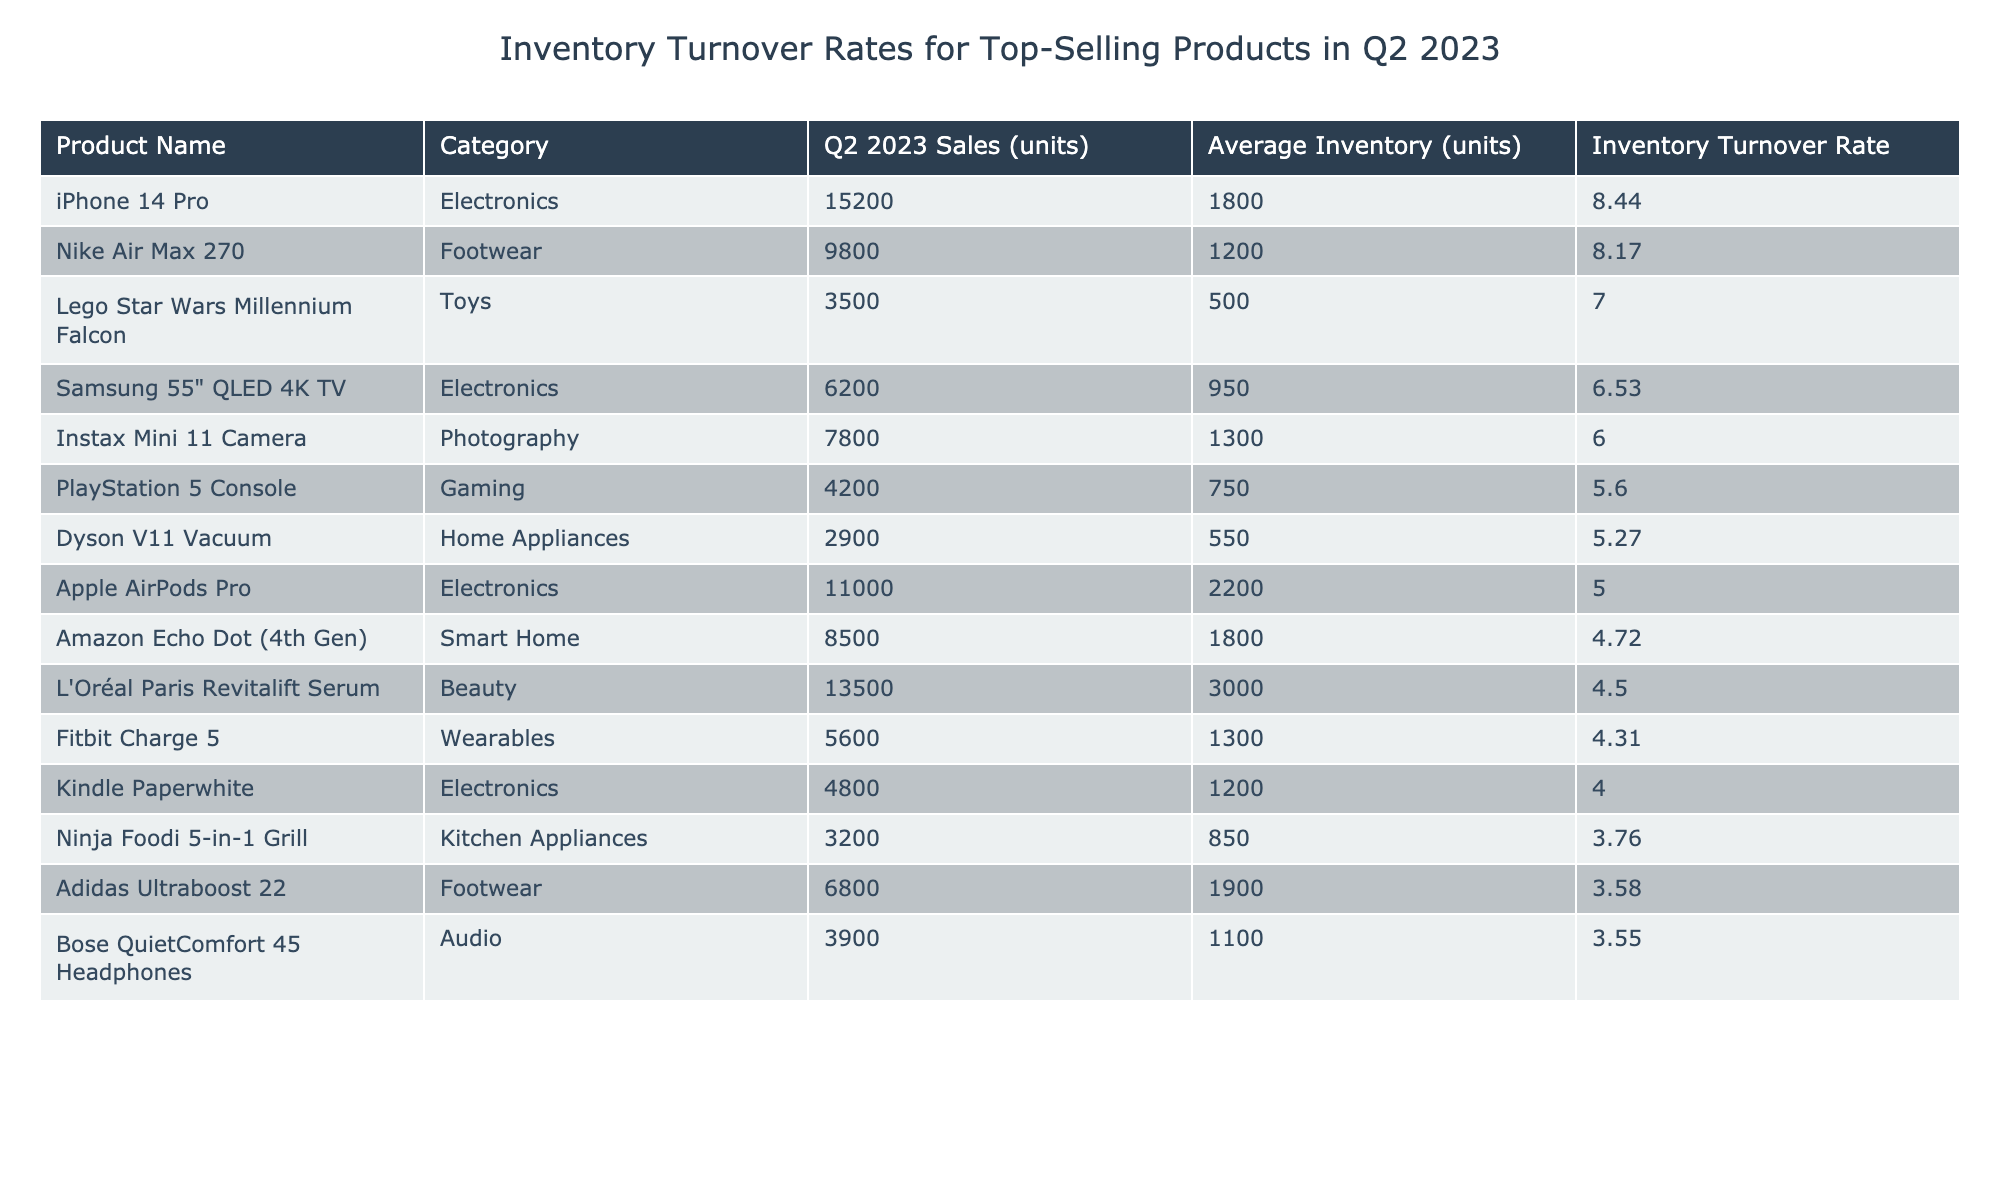What is the highest inventory turnover rate among the listed products? The highest inventory turnover rate is found by visually scanning the "Inventory Turnover Rate" column and identifying the top value, which is 8.44 for the iPhone 14 Pro.
Answer: 8.44 Which product has the lowest inventory turnover rate? The product with the lowest inventory turnover rate can be determined by looking for the smallest value in the "Inventory Turnover Rate" column, which is 3.55 for the Bose QuietComfort 45 Headphones.
Answer: 3.55 How many units of the PlayStation 5 Console were sold in Q2 2023? The Q2 2023 sales can be found by referring to the "Q2 2023 Sales (units)" column and looking for the corresponding row for the PlayStation 5 Console, which shows sales of 4200 units.
Answer: 4200 What is the average inventory turnover rate of all products listed? The average inventory turnover rate can be calculated by summing all turnover rates and dividing by the number of products. Adding the rates gives a total of 61.19 and dividing by 15 products results in approximately 4.08.
Answer: 4.08 Is the inventory turnover rate for the Amazon Echo Dot (4th Gen) above or below the average inventory turnover rate? First, we need to calculate the average turnover rate, which is 4.08. Then, comparing this with the turnover rate for the Amazon Echo Dot (4th Gen), which is 4.72, we can conclude that 4.72 is above 4.08.
Answer: Above How many more units of the Nike Air Max 270 were sold compared to the Dyson V11 Vacuum? To find this, we can subtract the sales of the Dyson V11 Vacuum (2900 units) from the sales of the Nike Air Max 270 (9800 units). Thus, 9800 - 2900 = 6900.
Answer: 6900 Among the products listed, which category has the highest average turnover rate? To find the category with the highest average turnover rate, we would calculate the average turnover for each category based on the products listed. The Electronics category has the highest values compared to other categories, particularly with the iPhone 14 Pro leading.
Answer: Electronics What is the total number of units sold for the top three products with the highest sales? To find the total, we can add the sales of the top three products: iPhone 14 Pro (15200) + Nike Air Max 270 (9800) + L'Oréal Paris Revitalift Serum (13500). The total comes out to 38500 units.
Answer: 38500 Does the average inventory for the Toys category exceed that of the Electronics category? We will find the average inventory of each category. For Toys: average of 500 (Lego) and for Electronics: average of (1800 + 2200 + 1200 + 950 + 4800) = 10400/5 = 2080. Since 500 is less than 2080, the average inventory for Toys does not exceed that of Electronics.
Answer: No What product has a sales count closest to the average sales of all products listed? The average sales can be calculated as total sales divided by the number of products. The total sales are 30,700 units, and the average is approximately 5,046.67. The product closest to this value is the Kindle Paperwhite with sales of 4800 units.
Answer: Kindle Paperwhite Which product has significantly higher sales than its average inventory, and what’s the difference? By checking products with high sales relative to their average inventory, we see the iPhone 14 Pro's sales of 15200 units against its inventory of 1800 units. The difference is calculated as 15200 - 1800 = 13400.
Answer: iPhone 14 Pro, 13400 